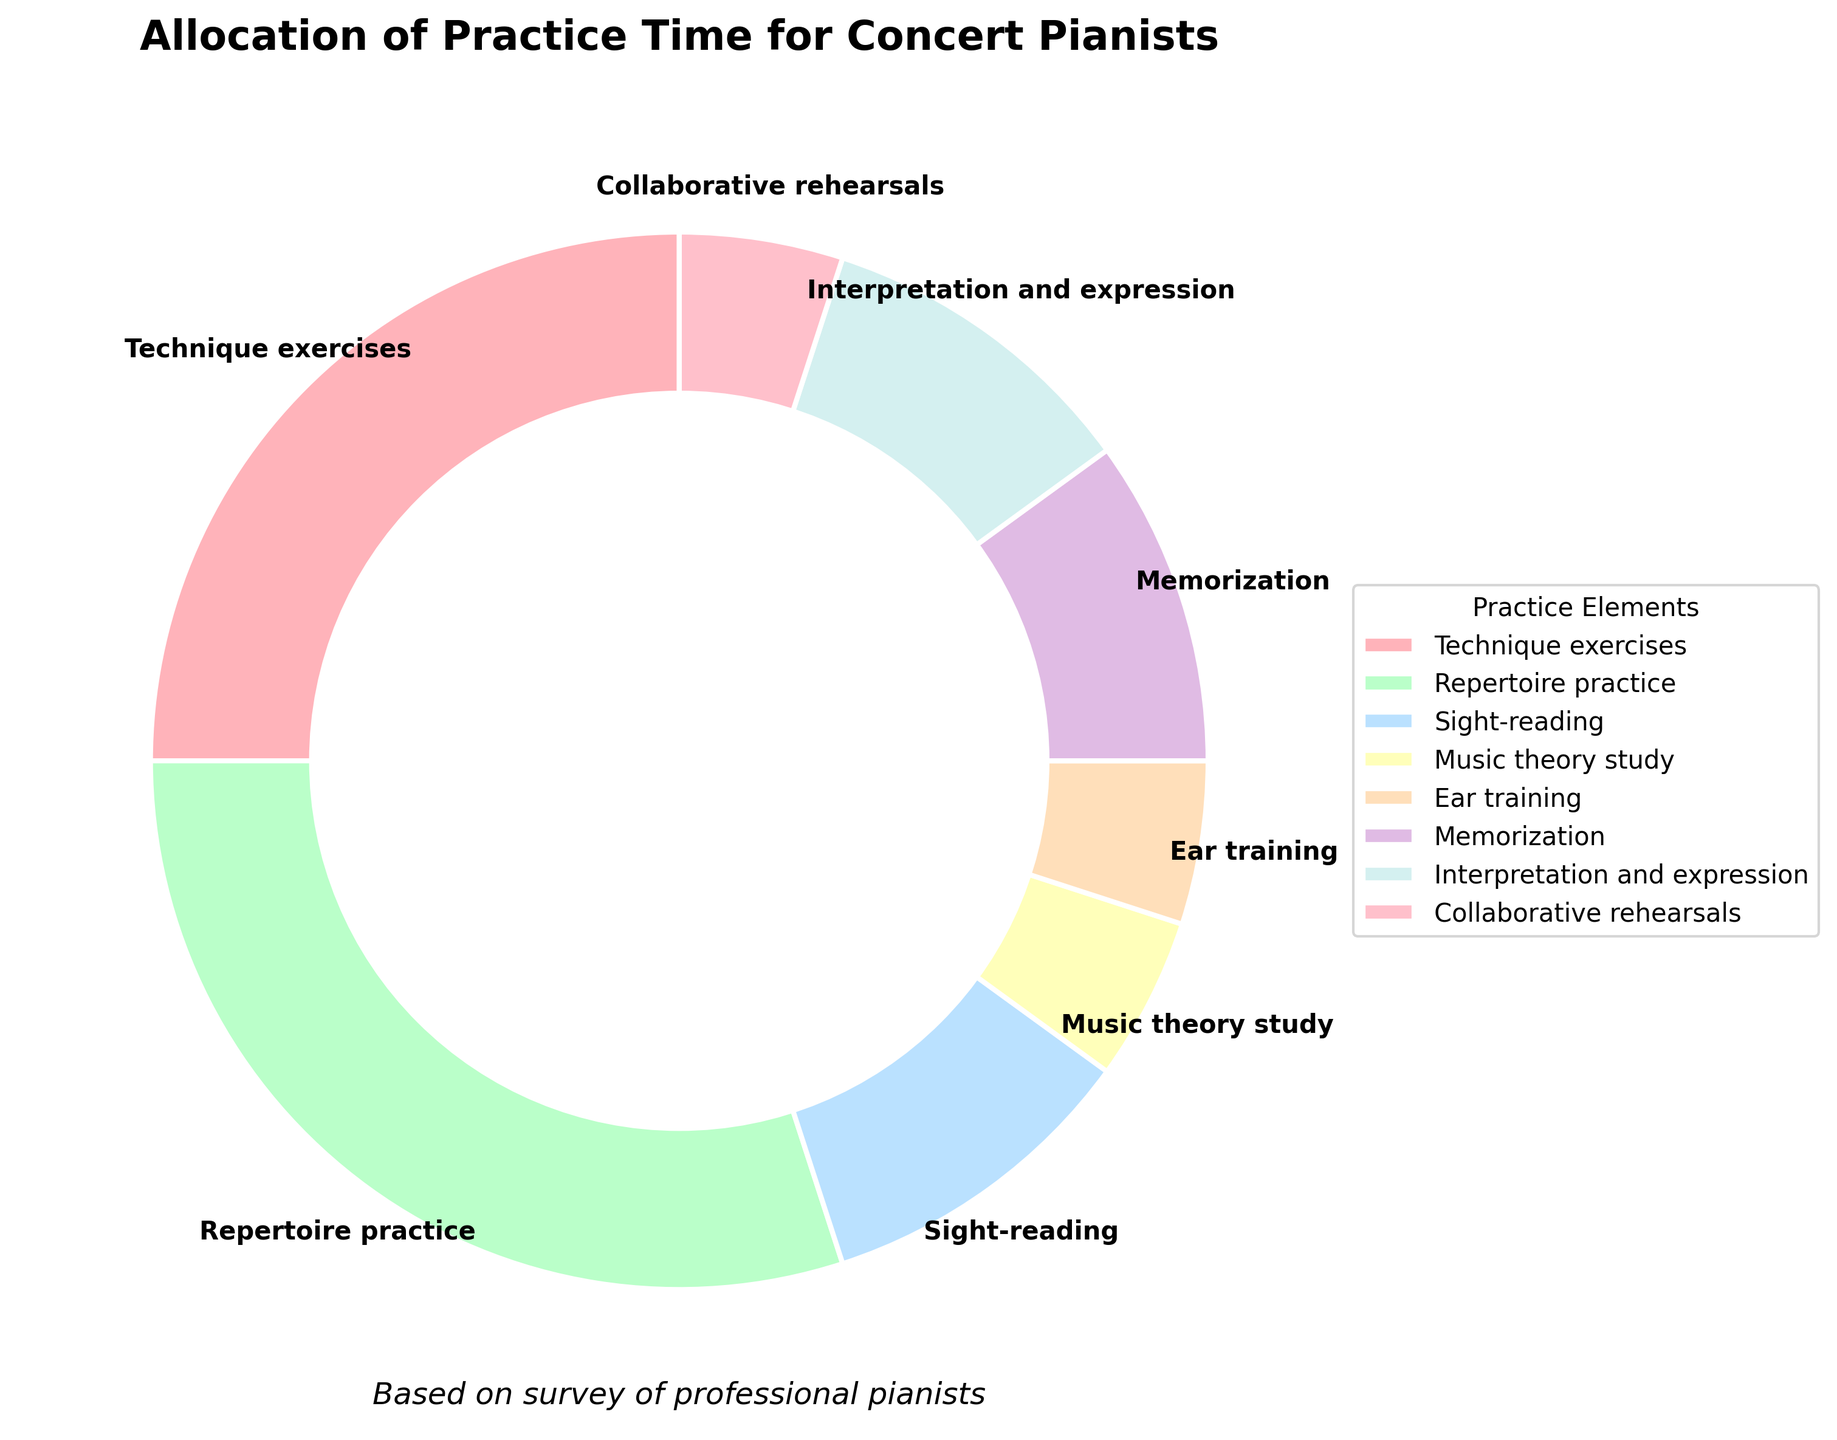Which practice element gets the highest allocation of time? The practice element with the highest percentage in the pie chart represents the highest allocation of practice time. According to the chart, "Repertoire practice" has the highest percentage.
Answer: Repertoire practice What is the combined percentage of time spent on Music theory study, Ear training, and Collaborative rehearsals? To find the combined percentage, sum the percentages of "Music theory study" (5%), "Ear training" (5%), and "Collaborative rehearsals" (5%). Thus, 5 + 5 + 5 = 15.
Answer: 15% How does time allocation for Technique exercises compare to Memorization? Compare the percentages of Technique exercises (25%) and Memorization (10%). Technique exercises have a higher allocation than Memorization.
Answer: Technique exercises have higher allocation What is the percentage difference between Repertoire practice and Interpretation and expression? Subtract the percentage of Interpretation and expression (10%) from Repertoire practice (30%): 30 - 10 = 20.
Answer: 20% What element shares the same percentage allocation as Memorization? The element that has the same percentage as Memorization (10%) is "Sight-reading" and "Interpretation and expression", both having 10%.
Answer: Sight-reading and Interpretation and expression Which practice element has the least time allocated to it, and what is its percentage? The practice elements that share the least allocation each have 5%: Music theory study, Ear training, and Collaborative rehearsals.
Answer: Music theory study, Ear training, and Collaborative rehearsals; 5% How much more time is allocated to Technique exercises compared to Ear training? Subtract the percentage of Ear training (5%) from Technique exercises (25%): 25 - 5 = 20.
Answer: 20% Which two elements combined have a time allocation equal to Repertoire practice? The elements with a combined percentage of 30%, which equals Repertoire practice, are Technique exercises (25%) and Ear training (5%). Thus, 25 + 5 = 30.
Answer: Technique exercises and Ear training What is the total allocation percentage for elements related to music literacy (including sights-reading and music theory study)? To find the total allocation, sum the percentages of Sight-reading (10%) and Music theory study (5%). Thus, 10 + 5 = 15.
Answer: 15% What fraction of time is spent on Interpretational elements (Interpretation and expression) compared to Technical elements (Technique exercises)? Compare the percentages: Interpretation and expression (10%) and Technique exercises (25%). The fraction is 10/25, which simplifies to 2/5.
Answer: 2/5 